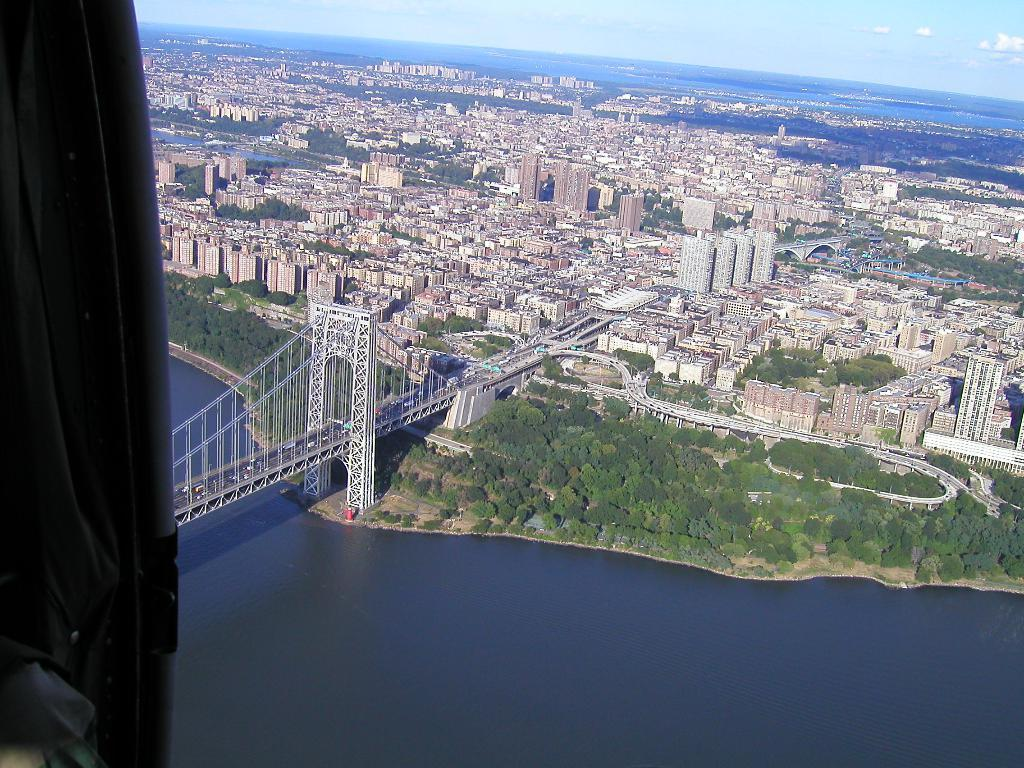What is the perspective of the image? The image is a top view of an airplane. What type of structures can be seen in the image? There are buildings visible in the image. What type of transportation infrastructure is present in the image? Roads and bridges are visible in the image. What type of natural elements are present in the image? Trees and rivers are visible in the image. How many cents are visible in the image? There are no cents present in the image. What thoughts are being expressed by the trees in the image? Trees do not express thoughts, so this cannot be answered. 